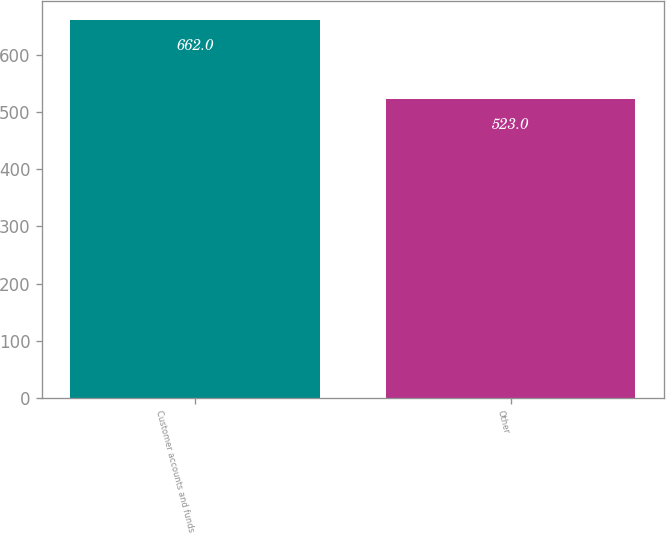<chart> <loc_0><loc_0><loc_500><loc_500><bar_chart><fcel>Customer accounts and funds<fcel>Other<nl><fcel>662<fcel>523<nl></chart> 